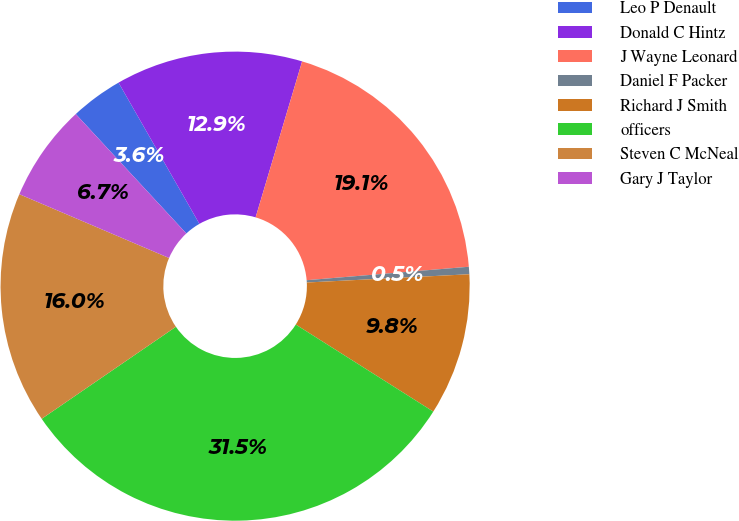Convert chart. <chart><loc_0><loc_0><loc_500><loc_500><pie_chart><fcel>Leo P Denault<fcel>Donald C Hintz<fcel>J Wayne Leonard<fcel>Daniel F Packer<fcel>Richard J Smith<fcel>officers<fcel>Steven C McNeal<fcel>Gary J Taylor<nl><fcel>3.61%<fcel>12.89%<fcel>19.07%<fcel>0.51%<fcel>9.79%<fcel>31.45%<fcel>15.98%<fcel>6.7%<nl></chart> 